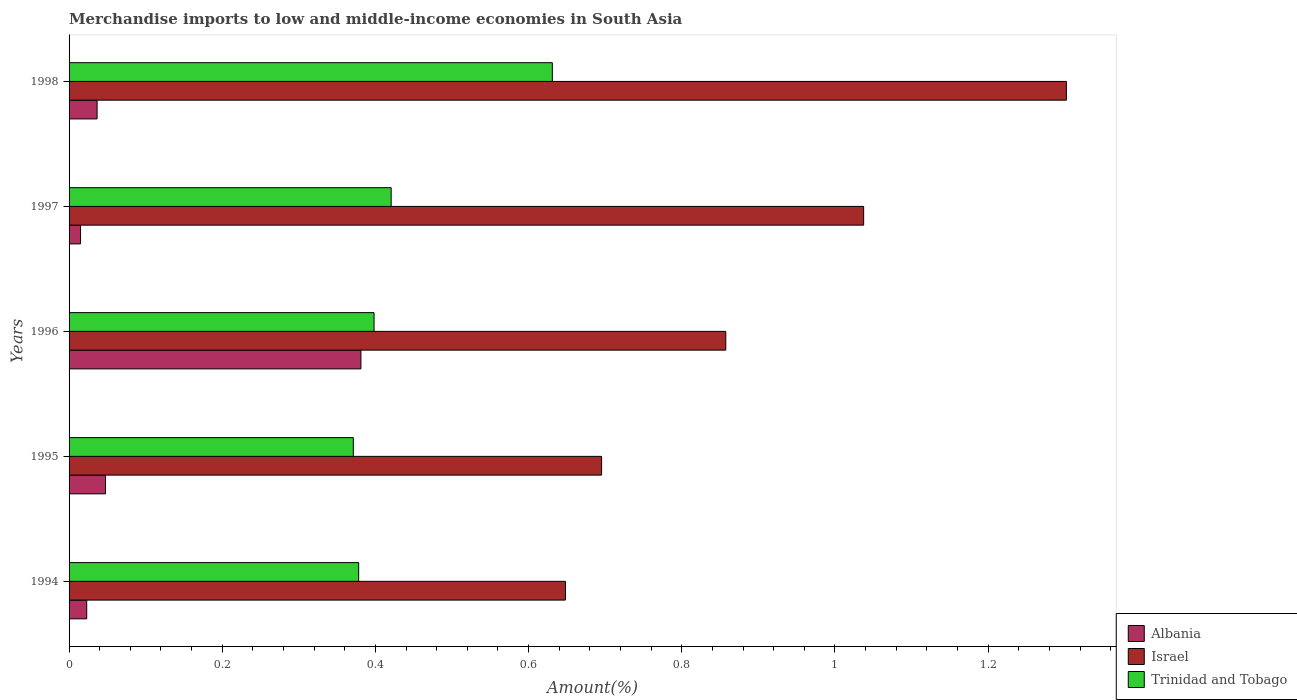How many different coloured bars are there?
Provide a short and direct response. 3. Are the number of bars on each tick of the Y-axis equal?
Ensure brevity in your answer.  Yes. What is the label of the 1st group of bars from the top?
Offer a very short reply. 1998. In how many cases, is the number of bars for a given year not equal to the number of legend labels?
Keep it short and to the point. 0. What is the percentage of amount earned from merchandise imports in Trinidad and Tobago in 1995?
Keep it short and to the point. 0.37. Across all years, what is the maximum percentage of amount earned from merchandise imports in Trinidad and Tobago?
Give a very brief answer. 0.63. Across all years, what is the minimum percentage of amount earned from merchandise imports in Albania?
Provide a succinct answer. 0.01. In which year was the percentage of amount earned from merchandise imports in Albania minimum?
Provide a succinct answer. 1997. What is the total percentage of amount earned from merchandise imports in Trinidad and Tobago in the graph?
Your answer should be compact. 2.2. What is the difference between the percentage of amount earned from merchandise imports in Trinidad and Tobago in 1994 and that in 1997?
Your answer should be compact. -0.04. What is the difference between the percentage of amount earned from merchandise imports in Trinidad and Tobago in 1994 and the percentage of amount earned from merchandise imports in Albania in 1995?
Your answer should be compact. 0.33. What is the average percentage of amount earned from merchandise imports in Israel per year?
Make the answer very short. 0.91. In the year 1998, what is the difference between the percentage of amount earned from merchandise imports in Trinidad and Tobago and percentage of amount earned from merchandise imports in Albania?
Ensure brevity in your answer.  0.59. In how many years, is the percentage of amount earned from merchandise imports in Trinidad and Tobago greater than 0.7200000000000001 %?
Give a very brief answer. 0. What is the ratio of the percentage of amount earned from merchandise imports in Trinidad and Tobago in 1994 to that in 1998?
Ensure brevity in your answer.  0.6. What is the difference between the highest and the second highest percentage of amount earned from merchandise imports in Albania?
Give a very brief answer. 0.33. What is the difference between the highest and the lowest percentage of amount earned from merchandise imports in Trinidad and Tobago?
Make the answer very short. 0.26. In how many years, is the percentage of amount earned from merchandise imports in Trinidad and Tobago greater than the average percentage of amount earned from merchandise imports in Trinidad and Tobago taken over all years?
Offer a very short reply. 1. Is the sum of the percentage of amount earned from merchandise imports in Trinidad and Tobago in 1995 and 1996 greater than the maximum percentage of amount earned from merchandise imports in Albania across all years?
Your answer should be compact. Yes. What does the 3rd bar from the top in 1997 represents?
Offer a terse response. Albania. What does the 3rd bar from the bottom in 1995 represents?
Provide a short and direct response. Trinidad and Tobago. Is it the case that in every year, the sum of the percentage of amount earned from merchandise imports in Albania and percentage of amount earned from merchandise imports in Trinidad and Tobago is greater than the percentage of amount earned from merchandise imports in Israel?
Offer a very short reply. No. Are all the bars in the graph horizontal?
Give a very brief answer. Yes. What is the difference between two consecutive major ticks on the X-axis?
Give a very brief answer. 0.2. Where does the legend appear in the graph?
Your response must be concise. Bottom right. How many legend labels are there?
Give a very brief answer. 3. How are the legend labels stacked?
Make the answer very short. Vertical. What is the title of the graph?
Offer a very short reply. Merchandise imports to low and middle-income economies in South Asia. What is the label or title of the X-axis?
Your response must be concise. Amount(%). What is the Amount(%) of Albania in 1994?
Offer a very short reply. 0.02. What is the Amount(%) of Israel in 1994?
Provide a succinct answer. 0.65. What is the Amount(%) in Trinidad and Tobago in 1994?
Provide a short and direct response. 0.38. What is the Amount(%) in Albania in 1995?
Keep it short and to the point. 0.05. What is the Amount(%) of Israel in 1995?
Offer a very short reply. 0.7. What is the Amount(%) of Trinidad and Tobago in 1995?
Ensure brevity in your answer.  0.37. What is the Amount(%) of Albania in 1996?
Keep it short and to the point. 0.38. What is the Amount(%) of Israel in 1996?
Keep it short and to the point. 0.86. What is the Amount(%) of Trinidad and Tobago in 1996?
Offer a terse response. 0.4. What is the Amount(%) of Albania in 1997?
Keep it short and to the point. 0.01. What is the Amount(%) in Israel in 1997?
Make the answer very short. 1.04. What is the Amount(%) of Trinidad and Tobago in 1997?
Your response must be concise. 0.42. What is the Amount(%) in Albania in 1998?
Make the answer very short. 0.04. What is the Amount(%) of Israel in 1998?
Offer a terse response. 1.3. What is the Amount(%) in Trinidad and Tobago in 1998?
Make the answer very short. 0.63. Across all years, what is the maximum Amount(%) in Albania?
Your answer should be compact. 0.38. Across all years, what is the maximum Amount(%) in Israel?
Your answer should be very brief. 1.3. Across all years, what is the maximum Amount(%) of Trinidad and Tobago?
Offer a very short reply. 0.63. Across all years, what is the minimum Amount(%) of Albania?
Your answer should be very brief. 0.01. Across all years, what is the minimum Amount(%) in Israel?
Offer a very short reply. 0.65. Across all years, what is the minimum Amount(%) in Trinidad and Tobago?
Offer a terse response. 0.37. What is the total Amount(%) of Albania in the graph?
Your answer should be compact. 0.5. What is the total Amount(%) in Israel in the graph?
Provide a succinct answer. 4.54. What is the total Amount(%) in Trinidad and Tobago in the graph?
Provide a succinct answer. 2.2. What is the difference between the Amount(%) in Albania in 1994 and that in 1995?
Offer a terse response. -0.02. What is the difference between the Amount(%) in Israel in 1994 and that in 1995?
Keep it short and to the point. -0.05. What is the difference between the Amount(%) in Trinidad and Tobago in 1994 and that in 1995?
Ensure brevity in your answer.  0.01. What is the difference between the Amount(%) in Albania in 1994 and that in 1996?
Make the answer very short. -0.36. What is the difference between the Amount(%) in Israel in 1994 and that in 1996?
Provide a succinct answer. -0.21. What is the difference between the Amount(%) in Trinidad and Tobago in 1994 and that in 1996?
Your answer should be very brief. -0.02. What is the difference between the Amount(%) of Albania in 1994 and that in 1997?
Make the answer very short. 0.01. What is the difference between the Amount(%) of Israel in 1994 and that in 1997?
Ensure brevity in your answer.  -0.39. What is the difference between the Amount(%) of Trinidad and Tobago in 1994 and that in 1997?
Your answer should be compact. -0.04. What is the difference between the Amount(%) of Albania in 1994 and that in 1998?
Ensure brevity in your answer.  -0.01. What is the difference between the Amount(%) in Israel in 1994 and that in 1998?
Offer a terse response. -0.65. What is the difference between the Amount(%) of Trinidad and Tobago in 1994 and that in 1998?
Offer a very short reply. -0.25. What is the difference between the Amount(%) in Albania in 1995 and that in 1996?
Your answer should be compact. -0.33. What is the difference between the Amount(%) of Israel in 1995 and that in 1996?
Give a very brief answer. -0.16. What is the difference between the Amount(%) in Trinidad and Tobago in 1995 and that in 1996?
Your response must be concise. -0.03. What is the difference between the Amount(%) of Albania in 1995 and that in 1997?
Make the answer very short. 0.03. What is the difference between the Amount(%) in Israel in 1995 and that in 1997?
Your answer should be compact. -0.34. What is the difference between the Amount(%) in Trinidad and Tobago in 1995 and that in 1997?
Your answer should be compact. -0.05. What is the difference between the Amount(%) of Albania in 1995 and that in 1998?
Keep it short and to the point. 0.01. What is the difference between the Amount(%) in Israel in 1995 and that in 1998?
Keep it short and to the point. -0.61. What is the difference between the Amount(%) in Trinidad and Tobago in 1995 and that in 1998?
Your response must be concise. -0.26. What is the difference between the Amount(%) of Albania in 1996 and that in 1997?
Make the answer very short. 0.37. What is the difference between the Amount(%) in Israel in 1996 and that in 1997?
Your answer should be compact. -0.18. What is the difference between the Amount(%) of Trinidad and Tobago in 1996 and that in 1997?
Give a very brief answer. -0.02. What is the difference between the Amount(%) in Albania in 1996 and that in 1998?
Make the answer very short. 0.34. What is the difference between the Amount(%) in Israel in 1996 and that in 1998?
Ensure brevity in your answer.  -0.44. What is the difference between the Amount(%) in Trinidad and Tobago in 1996 and that in 1998?
Make the answer very short. -0.23. What is the difference between the Amount(%) in Albania in 1997 and that in 1998?
Keep it short and to the point. -0.02. What is the difference between the Amount(%) of Israel in 1997 and that in 1998?
Your answer should be very brief. -0.26. What is the difference between the Amount(%) of Trinidad and Tobago in 1997 and that in 1998?
Make the answer very short. -0.21. What is the difference between the Amount(%) in Albania in 1994 and the Amount(%) in Israel in 1995?
Provide a short and direct response. -0.67. What is the difference between the Amount(%) of Albania in 1994 and the Amount(%) of Trinidad and Tobago in 1995?
Ensure brevity in your answer.  -0.35. What is the difference between the Amount(%) of Israel in 1994 and the Amount(%) of Trinidad and Tobago in 1995?
Give a very brief answer. 0.28. What is the difference between the Amount(%) of Albania in 1994 and the Amount(%) of Israel in 1996?
Offer a terse response. -0.83. What is the difference between the Amount(%) in Albania in 1994 and the Amount(%) in Trinidad and Tobago in 1996?
Offer a terse response. -0.38. What is the difference between the Amount(%) in Israel in 1994 and the Amount(%) in Trinidad and Tobago in 1996?
Keep it short and to the point. 0.25. What is the difference between the Amount(%) in Albania in 1994 and the Amount(%) in Israel in 1997?
Make the answer very short. -1.01. What is the difference between the Amount(%) in Albania in 1994 and the Amount(%) in Trinidad and Tobago in 1997?
Offer a very short reply. -0.4. What is the difference between the Amount(%) in Israel in 1994 and the Amount(%) in Trinidad and Tobago in 1997?
Give a very brief answer. 0.23. What is the difference between the Amount(%) of Albania in 1994 and the Amount(%) of Israel in 1998?
Offer a very short reply. -1.28. What is the difference between the Amount(%) in Albania in 1994 and the Amount(%) in Trinidad and Tobago in 1998?
Keep it short and to the point. -0.61. What is the difference between the Amount(%) in Israel in 1994 and the Amount(%) in Trinidad and Tobago in 1998?
Make the answer very short. 0.02. What is the difference between the Amount(%) in Albania in 1995 and the Amount(%) in Israel in 1996?
Ensure brevity in your answer.  -0.81. What is the difference between the Amount(%) in Albania in 1995 and the Amount(%) in Trinidad and Tobago in 1996?
Provide a short and direct response. -0.35. What is the difference between the Amount(%) of Israel in 1995 and the Amount(%) of Trinidad and Tobago in 1996?
Ensure brevity in your answer.  0.3. What is the difference between the Amount(%) of Albania in 1995 and the Amount(%) of Israel in 1997?
Offer a terse response. -0.99. What is the difference between the Amount(%) in Albania in 1995 and the Amount(%) in Trinidad and Tobago in 1997?
Give a very brief answer. -0.37. What is the difference between the Amount(%) of Israel in 1995 and the Amount(%) of Trinidad and Tobago in 1997?
Give a very brief answer. 0.27. What is the difference between the Amount(%) in Albania in 1995 and the Amount(%) in Israel in 1998?
Offer a very short reply. -1.25. What is the difference between the Amount(%) in Albania in 1995 and the Amount(%) in Trinidad and Tobago in 1998?
Provide a succinct answer. -0.58. What is the difference between the Amount(%) of Israel in 1995 and the Amount(%) of Trinidad and Tobago in 1998?
Make the answer very short. 0.06. What is the difference between the Amount(%) of Albania in 1996 and the Amount(%) of Israel in 1997?
Make the answer very short. -0.66. What is the difference between the Amount(%) in Albania in 1996 and the Amount(%) in Trinidad and Tobago in 1997?
Provide a short and direct response. -0.04. What is the difference between the Amount(%) in Israel in 1996 and the Amount(%) in Trinidad and Tobago in 1997?
Give a very brief answer. 0.44. What is the difference between the Amount(%) in Albania in 1996 and the Amount(%) in Israel in 1998?
Give a very brief answer. -0.92. What is the difference between the Amount(%) in Albania in 1996 and the Amount(%) in Trinidad and Tobago in 1998?
Your answer should be compact. -0.25. What is the difference between the Amount(%) of Israel in 1996 and the Amount(%) of Trinidad and Tobago in 1998?
Your answer should be very brief. 0.23. What is the difference between the Amount(%) in Albania in 1997 and the Amount(%) in Israel in 1998?
Your response must be concise. -1.29. What is the difference between the Amount(%) in Albania in 1997 and the Amount(%) in Trinidad and Tobago in 1998?
Your answer should be very brief. -0.62. What is the difference between the Amount(%) of Israel in 1997 and the Amount(%) of Trinidad and Tobago in 1998?
Keep it short and to the point. 0.41. What is the average Amount(%) of Albania per year?
Offer a terse response. 0.1. What is the average Amount(%) of Israel per year?
Give a very brief answer. 0.91. What is the average Amount(%) of Trinidad and Tobago per year?
Your answer should be compact. 0.44. In the year 1994, what is the difference between the Amount(%) in Albania and Amount(%) in Israel?
Offer a terse response. -0.63. In the year 1994, what is the difference between the Amount(%) of Albania and Amount(%) of Trinidad and Tobago?
Make the answer very short. -0.36. In the year 1994, what is the difference between the Amount(%) of Israel and Amount(%) of Trinidad and Tobago?
Your response must be concise. 0.27. In the year 1995, what is the difference between the Amount(%) in Albania and Amount(%) in Israel?
Make the answer very short. -0.65. In the year 1995, what is the difference between the Amount(%) in Albania and Amount(%) in Trinidad and Tobago?
Offer a very short reply. -0.32. In the year 1995, what is the difference between the Amount(%) of Israel and Amount(%) of Trinidad and Tobago?
Your answer should be very brief. 0.32. In the year 1996, what is the difference between the Amount(%) of Albania and Amount(%) of Israel?
Ensure brevity in your answer.  -0.48. In the year 1996, what is the difference between the Amount(%) of Albania and Amount(%) of Trinidad and Tobago?
Keep it short and to the point. -0.02. In the year 1996, what is the difference between the Amount(%) in Israel and Amount(%) in Trinidad and Tobago?
Ensure brevity in your answer.  0.46. In the year 1997, what is the difference between the Amount(%) of Albania and Amount(%) of Israel?
Keep it short and to the point. -1.02. In the year 1997, what is the difference between the Amount(%) in Albania and Amount(%) in Trinidad and Tobago?
Give a very brief answer. -0.41. In the year 1997, what is the difference between the Amount(%) of Israel and Amount(%) of Trinidad and Tobago?
Make the answer very short. 0.62. In the year 1998, what is the difference between the Amount(%) of Albania and Amount(%) of Israel?
Offer a very short reply. -1.27. In the year 1998, what is the difference between the Amount(%) of Albania and Amount(%) of Trinidad and Tobago?
Keep it short and to the point. -0.59. In the year 1998, what is the difference between the Amount(%) in Israel and Amount(%) in Trinidad and Tobago?
Provide a succinct answer. 0.67. What is the ratio of the Amount(%) in Albania in 1994 to that in 1995?
Provide a succinct answer. 0.48. What is the ratio of the Amount(%) of Israel in 1994 to that in 1995?
Provide a short and direct response. 0.93. What is the ratio of the Amount(%) of Trinidad and Tobago in 1994 to that in 1995?
Your answer should be very brief. 1.02. What is the ratio of the Amount(%) in Albania in 1994 to that in 1996?
Your response must be concise. 0.06. What is the ratio of the Amount(%) in Israel in 1994 to that in 1996?
Your response must be concise. 0.76. What is the ratio of the Amount(%) in Trinidad and Tobago in 1994 to that in 1996?
Your answer should be compact. 0.95. What is the ratio of the Amount(%) in Albania in 1994 to that in 1997?
Provide a short and direct response. 1.54. What is the ratio of the Amount(%) in Israel in 1994 to that in 1997?
Give a very brief answer. 0.62. What is the ratio of the Amount(%) of Trinidad and Tobago in 1994 to that in 1997?
Provide a succinct answer. 0.9. What is the ratio of the Amount(%) of Albania in 1994 to that in 1998?
Offer a very short reply. 0.63. What is the ratio of the Amount(%) in Israel in 1994 to that in 1998?
Your response must be concise. 0.5. What is the ratio of the Amount(%) of Trinidad and Tobago in 1994 to that in 1998?
Provide a short and direct response. 0.6. What is the ratio of the Amount(%) in Albania in 1995 to that in 1996?
Your response must be concise. 0.12. What is the ratio of the Amount(%) in Israel in 1995 to that in 1996?
Your answer should be very brief. 0.81. What is the ratio of the Amount(%) of Trinidad and Tobago in 1995 to that in 1996?
Offer a terse response. 0.93. What is the ratio of the Amount(%) in Albania in 1995 to that in 1997?
Offer a terse response. 3.18. What is the ratio of the Amount(%) of Israel in 1995 to that in 1997?
Ensure brevity in your answer.  0.67. What is the ratio of the Amount(%) of Trinidad and Tobago in 1995 to that in 1997?
Your answer should be compact. 0.88. What is the ratio of the Amount(%) in Albania in 1995 to that in 1998?
Keep it short and to the point. 1.3. What is the ratio of the Amount(%) in Israel in 1995 to that in 1998?
Give a very brief answer. 0.53. What is the ratio of the Amount(%) in Trinidad and Tobago in 1995 to that in 1998?
Your response must be concise. 0.59. What is the ratio of the Amount(%) of Albania in 1996 to that in 1997?
Offer a very short reply. 25.44. What is the ratio of the Amount(%) of Israel in 1996 to that in 1997?
Offer a very short reply. 0.83. What is the ratio of the Amount(%) in Trinidad and Tobago in 1996 to that in 1997?
Make the answer very short. 0.95. What is the ratio of the Amount(%) in Albania in 1996 to that in 1998?
Your answer should be very brief. 10.41. What is the ratio of the Amount(%) of Israel in 1996 to that in 1998?
Your response must be concise. 0.66. What is the ratio of the Amount(%) in Trinidad and Tobago in 1996 to that in 1998?
Provide a succinct answer. 0.63. What is the ratio of the Amount(%) of Albania in 1997 to that in 1998?
Offer a terse response. 0.41. What is the ratio of the Amount(%) in Israel in 1997 to that in 1998?
Make the answer very short. 0.8. What is the ratio of the Amount(%) of Trinidad and Tobago in 1997 to that in 1998?
Offer a very short reply. 0.67. What is the difference between the highest and the second highest Amount(%) of Albania?
Provide a short and direct response. 0.33. What is the difference between the highest and the second highest Amount(%) of Israel?
Provide a short and direct response. 0.26. What is the difference between the highest and the second highest Amount(%) of Trinidad and Tobago?
Your response must be concise. 0.21. What is the difference between the highest and the lowest Amount(%) in Albania?
Give a very brief answer. 0.37. What is the difference between the highest and the lowest Amount(%) in Israel?
Your response must be concise. 0.65. What is the difference between the highest and the lowest Amount(%) of Trinidad and Tobago?
Offer a very short reply. 0.26. 